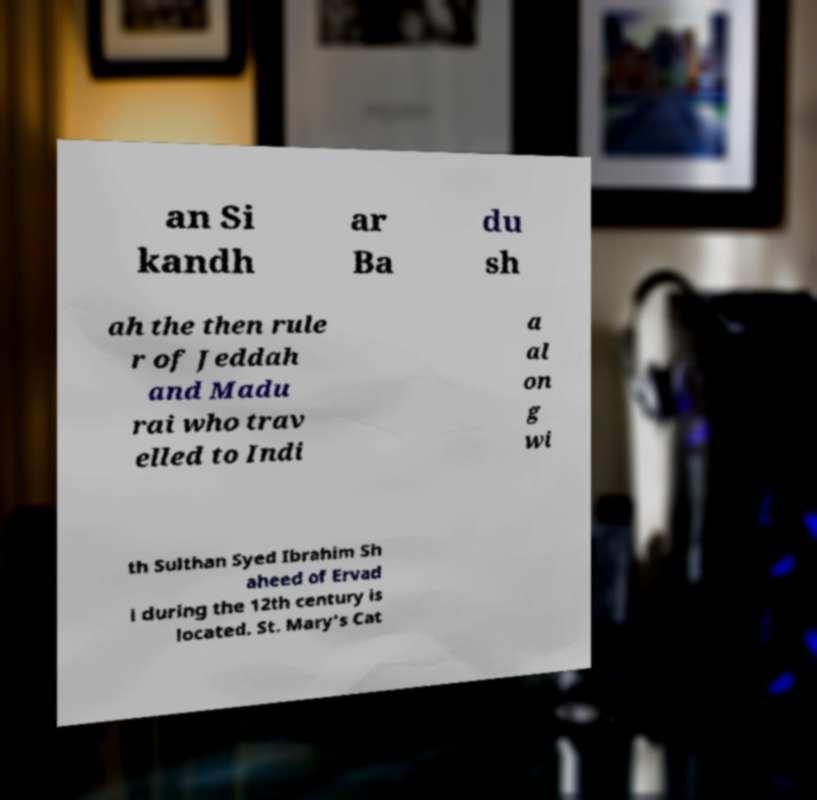For documentation purposes, I need the text within this image transcribed. Could you provide that? an Si kandh ar Ba du sh ah the then rule r of Jeddah and Madu rai who trav elled to Indi a al on g wi th Sulthan Syed Ibrahim Sh aheed of Ervad i during the 12th century is located. St. Mary's Cat 